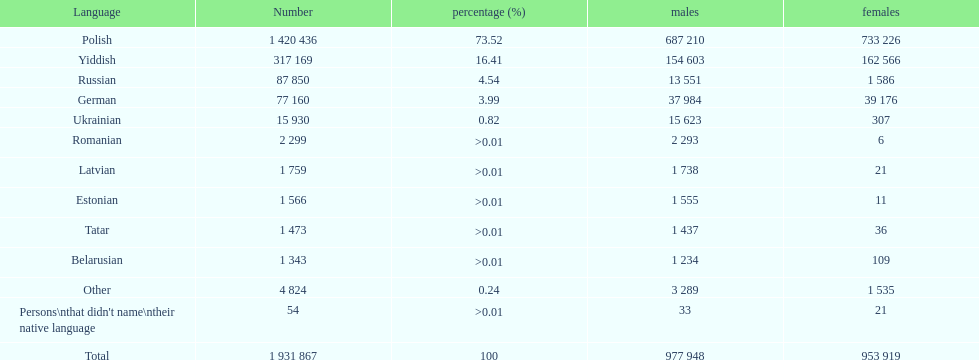What is the greatest proportion of speakers besides polish? Yiddish. 